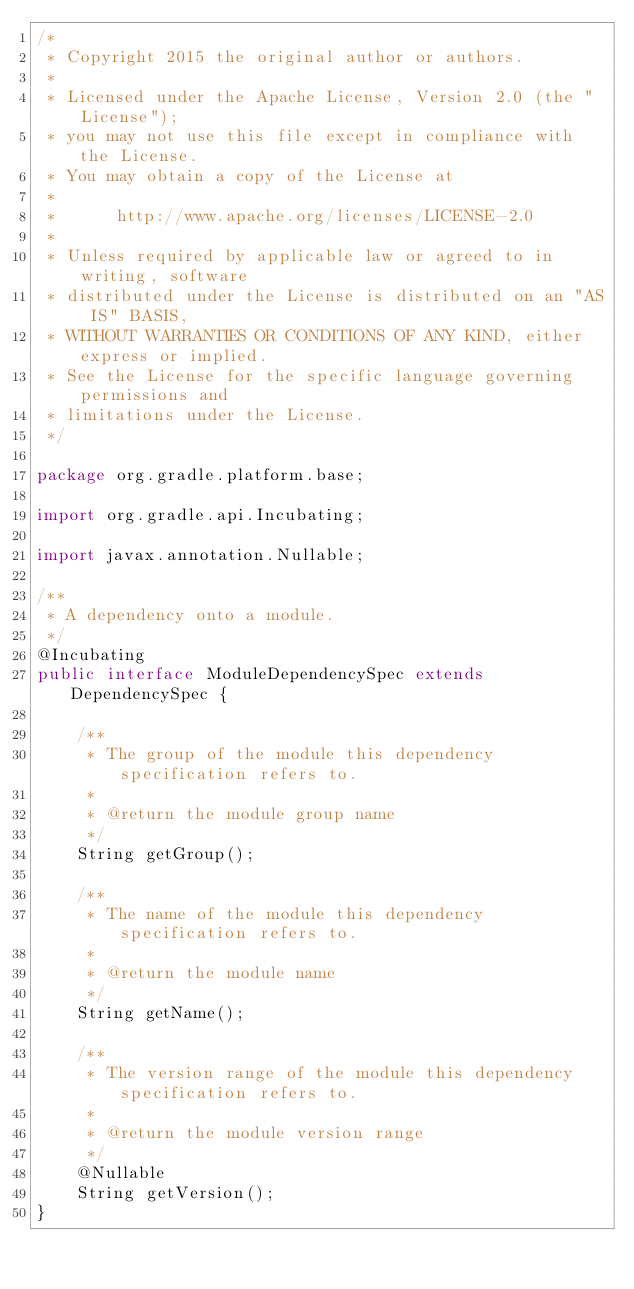Convert code to text. <code><loc_0><loc_0><loc_500><loc_500><_Java_>/*
 * Copyright 2015 the original author or authors.
 *
 * Licensed under the Apache License, Version 2.0 (the "License");
 * you may not use this file except in compliance with the License.
 * You may obtain a copy of the License at
 *
 *      http://www.apache.org/licenses/LICENSE-2.0
 *
 * Unless required by applicable law or agreed to in writing, software
 * distributed under the License is distributed on an "AS IS" BASIS,
 * WITHOUT WARRANTIES OR CONDITIONS OF ANY KIND, either express or implied.
 * See the License for the specific language governing permissions and
 * limitations under the License.
 */

package org.gradle.platform.base;

import org.gradle.api.Incubating;

import javax.annotation.Nullable;

/**
 * A dependency onto a module.
 */
@Incubating
public interface ModuleDependencySpec extends DependencySpec {

    /**
     * The group of the module this dependency specification refers to.
     *
     * @return the module group name
     */
    String getGroup();

    /**
     * The name of the module this dependency specification refers to.
     *
     * @return the module name
     */
    String getName();

    /**
     * The version range of the module this dependency specification refers to.
     *
     * @return the module version range
     */
    @Nullable
    String getVersion();
}
</code> 